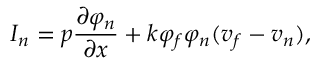<formula> <loc_0><loc_0><loc_500><loc_500>I _ { n } = p \frac { \partial \varphi _ { n } } { \partial x } + k \varphi _ { f } \varphi _ { n } ( v _ { f } - v _ { n } ) ,</formula> 